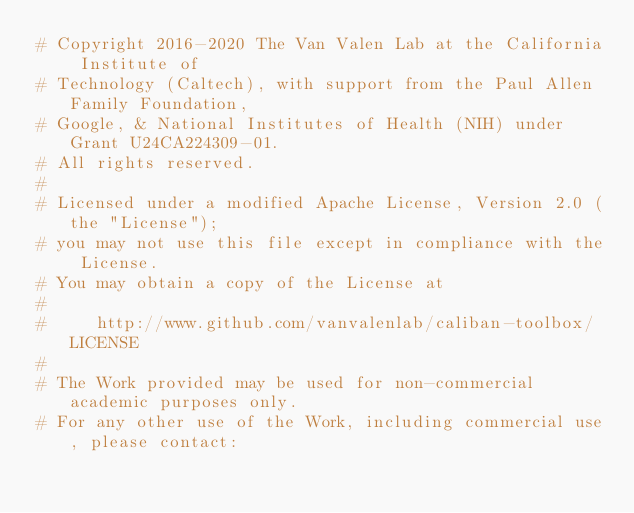Convert code to text. <code><loc_0><loc_0><loc_500><loc_500><_Python_># Copyright 2016-2020 The Van Valen Lab at the California Institute of
# Technology (Caltech), with support from the Paul Allen Family Foundation,
# Google, & National Institutes of Health (NIH) under Grant U24CA224309-01.
# All rights reserved.
#
# Licensed under a modified Apache License, Version 2.0 (the "License");
# you may not use this file except in compliance with the License.
# You may obtain a copy of the License at
#
#     http://www.github.com/vanvalenlab/caliban-toolbox/LICENSE
#
# The Work provided may be used for non-commercial academic purposes only.
# For any other use of the Work, including commercial use, please contact:</code> 